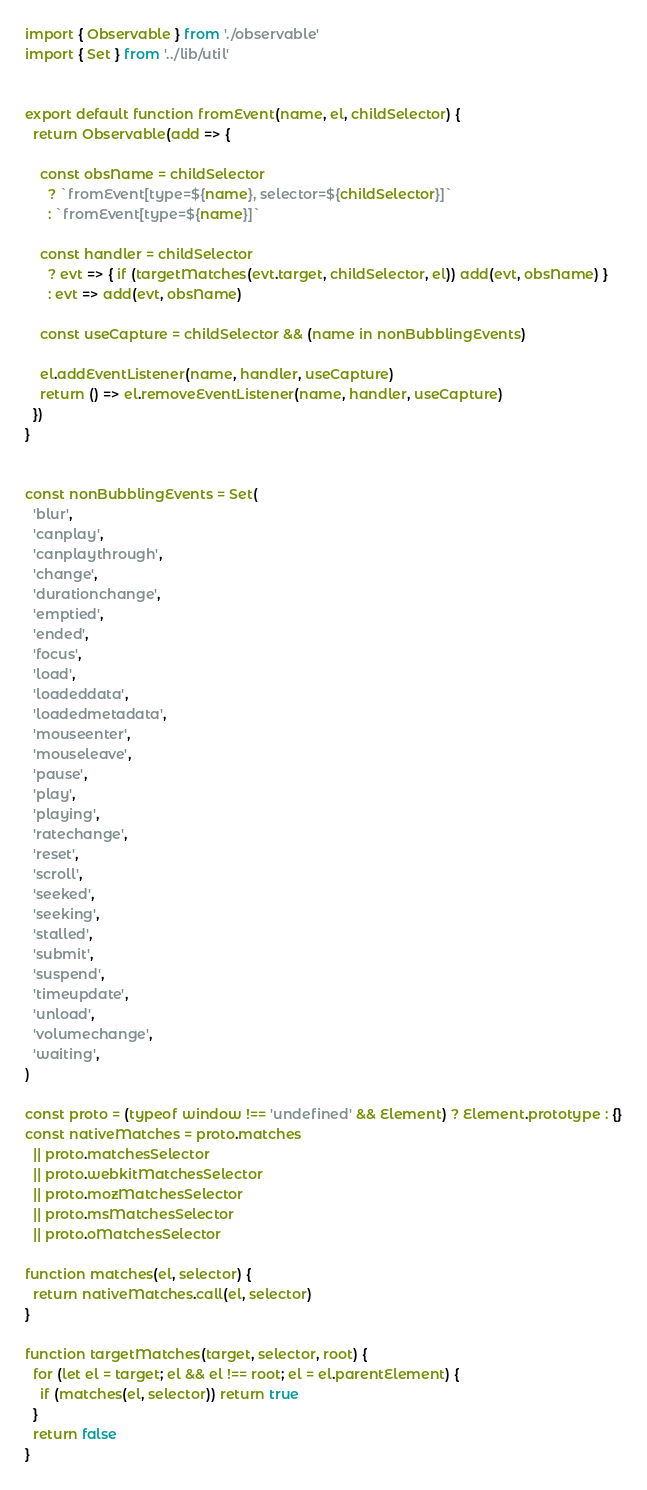<code> <loc_0><loc_0><loc_500><loc_500><_JavaScript_>import { Observable } from './observable'
import { Set } from '../lib/util'


export default function fromEvent(name, el, childSelector) {
  return Observable(add => {

    const obsName = childSelector
      ? `fromEvent[type=${name}, selector=${childSelector}]`
      : `fromEvent[type=${name}]`

    const handler = childSelector
      ? evt => { if (targetMatches(evt.target, childSelector, el)) add(evt, obsName) }
      : evt => add(evt, obsName)

    const useCapture = childSelector && (name in nonBubblingEvents)

    el.addEventListener(name, handler, useCapture)
    return () => el.removeEventListener(name, handler, useCapture)
  })
}


const nonBubblingEvents = Set(
  'blur',
  'canplay',
  'canplaythrough',
  'change',
  'durationchange',
  'emptied',
  'ended',
  'focus',
  'load',
  'loadeddata',
  'loadedmetadata',
  'mouseenter',
  'mouseleave',
  'pause',
  'play',
  'playing',
  'ratechange',
  'reset',
  'scroll',
  'seeked',
  'seeking',
  'stalled',
  'submit',
  'suspend',
  'timeupdate',
  'unload',
  'volumechange',
  'waiting',
)

const proto = (typeof window !== 'undefined' && Element) ? Element.prototype : {}
const nativeMatches = proto.matches
  || proto.matchesSelector
  || proto.webkitMatchesSelector
  || proto.mozMatchesSelector
  || proto.msMatchesSelector
  || proto.oMatchesSelector

function matches(el, selector) {
  return nativeMatches.call(el, selector)
}

function targetMatches(target, selector, root) {
  for (let el = target; el && el !== root; el = el.parentElement) {
    if (matches(el, selector)) return true
  }
  return false
}
</code> 